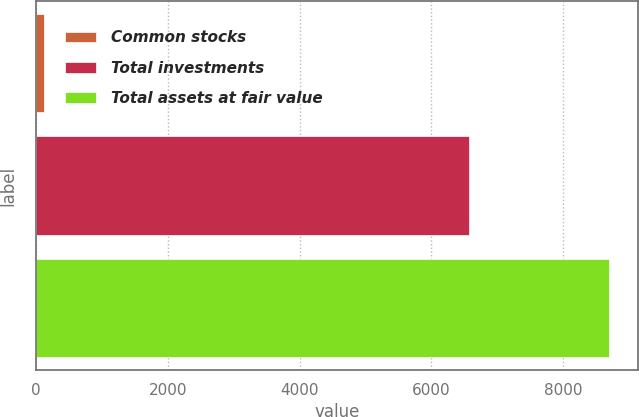<chart> <loc_0><loc_0><loc_500><loc_500><bar_chart><fcel>Common stocks<fcel>Total investments<fcel>Total assets at fair value<nl><fcel>123<fcel>6570<fcel>8705<nl></chart> 